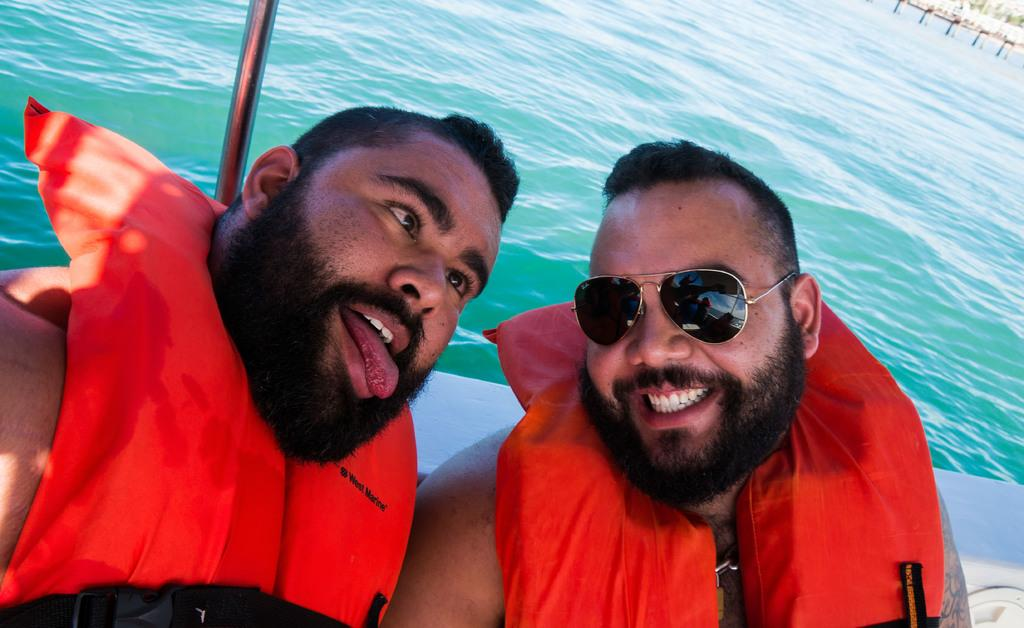How many people are in the image? There are two persons in the image. What can be seen in the image besides the people? There is a pole and water visible in the image, as well as a few unspecified objects. What type of house is visible in the image? There is no house present in the image. How does the addition of the pole affect the image? The addition of the pole does not change the image itself, as it is already present in the image. 